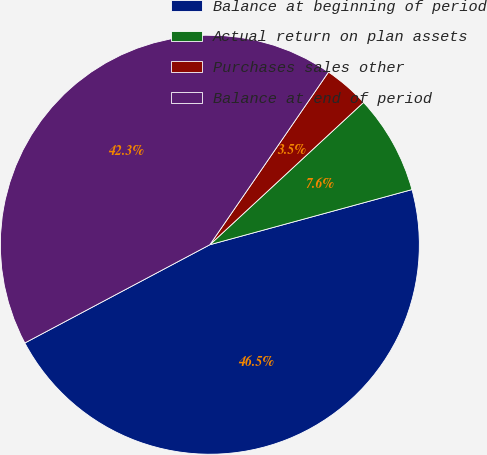Convert chart to OTSL. <chart><loc_0><loc_0><loc_500><loc_500><pie_chart><fcel>Balance at beginning of period<fcel>Actual return on plan assets<fcel>Purchases sales other<fcel>Balance at end of period<nl><fcel>46.47%<fcel>7.65%<fcel>3.53%<fcel>42.35%<nl></chart> 